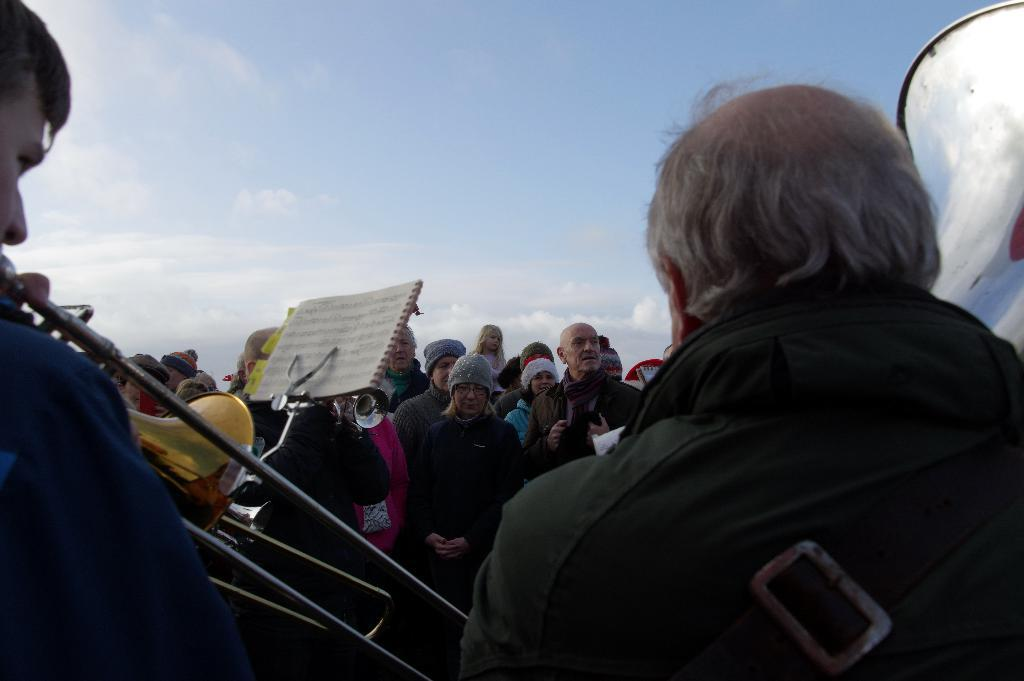What are the people in the image doing? The people in the image are standing. What specific action is being performed by one of the individuals? A man is playing a trumpet. What object can be seen in the image that is related to books? There is a bookstand in the image. How would you describe the sky in the image? The sky is blue and cloudy. What is the afterthought of the person holding the book on the bookstand? There is no person holding a book on the bookstand in the image, so it is not possible to determine their afterthought. --- Facts: 1. There is a car in the image. 2. The car is red. 3. The car has four wheels. 4. There is a road in the image. 5. The road is paved. Absurd Topics: parrot, ocean, emotion Conversation: What is the main subject of the image? The main subject of the image is a car. What color is the car? The car is red. How many wheels does the car have? The car has four wheels. What type of surface can be seen in the image? There is a road in the image, and it is paved. Reasoning: Let's think step by step in order to produce the conversation. We start by identifying the main subject of the image, which is the car. Then, we describe specific features of the car, such as its color and the number of wheels. Next, we observe the setting in which the car is located, noting that there is a road present. Finally, we describe the road's condition, which is paved, to give a sense of the quality of the infrastructure. Absurd Question/Answer: Can you tell me how many parrots are sitting on the car's roof in the image? There are no parrots present on the car's roof in the image. What emotion is the car displaying in the image? Cars do not have emotions, so this question cannot be answered. 